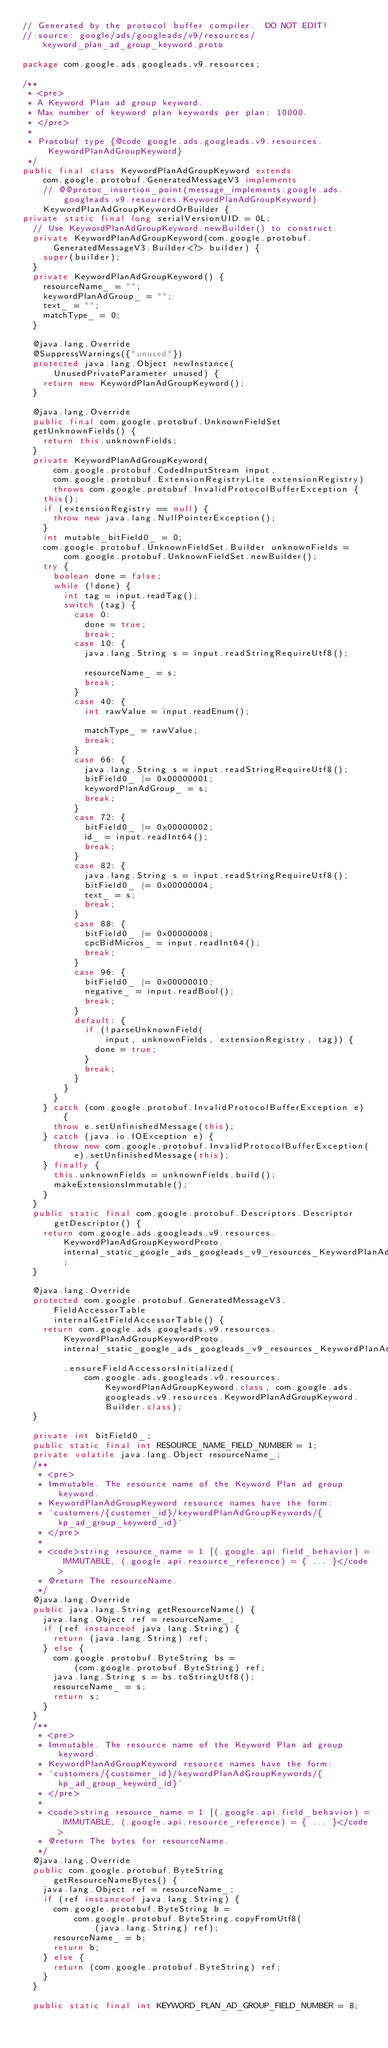Convert code to text. <code><loc_0><loc_0><loc_500><loc_500><_Java_>// Generated by the protocol buffer compiler.  DO NOT EDIT!
// source: google/ads/googleads/v9/resources/keyword_plan_ad_group_keyword.proto

package com.google.ads.googleads.v9.resources;

/**
 * <pre>
 * A Keyword Plan ad group keyword.
 * Max number of keyword plan keywords per plan: 10000.
 * </pre>
 *
 * Protobuf type {@code google.ads.googleads.v9.resources.KeywordPlanAdGroupKeyword}
 */
public final class KeywordPlanAdGroupKeyword extends
    com.google.protobuf.GeneratedMessageV3 implements
    // @@protoc_insertion_point(message_implements:google.ads.googleads.v9.resources.KeywordPlanAdGroupKeyword)
    KeywordPlanAdGroupKeywordOrBuilder {
private static final long serialVersionUID = 0L;
  // Use KeywordPlanAdGroupKeyword.newBuilder() to construct.
  private KeywordPlanAdGroupKeyword(com.google.protobuf.GeneratedMessageV3.Builder<?> builder) {
    super(builder);
  }
  private KeywordPlanAdGroupKeyword() {
    resourceName_ = "";
    keywordPlanAdGroup_ = "";
    text_ = "";
    matchType_ = 0;
  }

  @java.lang.Override
  @SuppressWarnings({"unused"})
  protected java.lang.Object newInstance(
      UnusedPrivateParameter unused) {
    return new KeywordPlanAdGroupKeyword();
  }

  @java.lang.Override
  public final com.google.protobuf.UnknownFieldSet
  getUnknownFields() {
    return this.unknownFields;
  }
  private KeywordPlanAdGroupKeyword(
      com.google.protobuf.CodedInputStream input,
      com.google.protobuf.ExtensionRegistryLite extensionRegistry)
      throws com.google.protobuf.InvalidProtocolBufferException {
    this();
    if (extensionRegistry == null) {
      throw new java.lang.NullPointerException();
    }
    int mutable_bitField0_ = 0;
    com.google.protobuf.UnknownFieldSet.Builder unknownFields =
        com.google.protobuf.UnknownFieldSet.newBuilder();
    try {
      boolean done = false;
      while (!done) {
        int tag = input.readTag();
        switch (tag) {
          case 0:
            done = true;
            break;
          case 10: {
            java.lang.String s = input.readStringRequireUtf8();

            resourceName_ = s;
            break;
          }
          case 40: {
            int rawValue = input.readEnum();

            matchType_ = rawValue;
            break;
          }
          case 66: {
            java.lang.String s = input.readStringRequireUtf8();
            bitField0_ |= 0x00000001;
            keywordPlanAdGroup_ = s;
            break;
          }
          case 72: {
            bitField0_ |= 0x00000002;
            id_ = input.readInt64();
            break;
          }
          case 82: {
            java.lang.String s = input.readStringRequireUtf8();
            bitField0_ |= 0x00000004;
            text_ = s;
            break;
          }
          case 88: {
            bitField0_ |= 0x00000008;
            cpcBidMicros_ = input.readInt64();
            break;
          }
          case 96: {
            bitField0_ |= 0x00000010;
            negative_ = input.readBool();
            break;
          }
          default: {
            if (!parseUnknownField(
                input, unknownFields, extensionRegistry, tag)) {
              done = true;
            }
            break;
          }
        }
      }
    } catch (com.google.protobuf.InvalidProtocolBufferException e) {
      throw e.setUnfinishedMessage(this);
    } catch (java.io.IOException e) {
      throw new com.google.protobuf.InvalidProtocolBufferException(
          e).setUnfinishedMessage(this);
    } finally {
      this.unknownFields = unknownFields.build();
      makeExtensionsImmutable();
    }
  }
  public static final com.google.protobuf.Descriptors.Descriptor
      getDescriptor() {
    return com.google.ads.googleads.v9.resources.KeywordPlanAdGroupKeywordProto.internal_static_google_ads_googleads_v9_resources_KeywordPlanAdGroupKeyword_descriptor;
  }

  @java.lang.Override
  protected com.google.protobuf.GeneratedMessageV3.FieldAccessorTable
      internalGetFieldAccessorTable() {
    return com.google.ads.googleads.v9.resources.KeywordPlanAdGroupKeywordProto.internal_static_google_ads_googleads_v9_resources_KeywordPlanAdGroupKeyword_fieldAccessorTable
        .ensureFieldAccessorsInitialized(
            com.google.ads.googleads.v9.resources.KeywordPlanAdGroupKeyword.class, com.google.ads.googleads.v9.resources.KeywordPlanAdGroupKeyword.Builder.class);
  }

  private int bitField0_;
  public static final int RESOURCE_NAME_FIELD_NUMBER = 1;
  private volatile java.lang.Object resourceName_;
  /**
   * <pre>
   * Immutable. The resource name of the Keyword Plan ad group keyword.
   * KeywordPlanAdGroupKeyword resource names have the form:
   * `customers/{customer_id}/keywordPlanAdGroupKeywords/{kp_ad_group_keyword_id}`
   * </pre>
   *
   * <code>string resource_name = 1 [(.google.api.field_behavior) = IMMUTABLE, (.google.api.resource_reference) = { ... }</code>
   * @return The resourceName.
   */
  @java.lang.Override
  public java.lang.String getResourceName() {
    java.lang.Object ref = resourceName_;
    if (ref instanceof java.lang.String) {
      return (java.lang.String) ref;
    } else {
      com.google.protobuf.ByteString bs = 
          (com.google.protobuf.ByteString) ref;
      java.lang.String s = bs.toStringUtf8();
      resourceName_ = s;
      return s;
    }
  }
  /**
   * <pre>
   * Immutable. The resource name of the Keyword Plan ad group keyword.
   * KeywordPlanAdGroupKeyword resource names have the form:
   * `customers/{customer_id}/keywordPlanAdGroupKeywords/{kp_ad_group_keyword_id}`
   * </pre>
   *
   * <code>string resource_name = 1 [(.google.api.field_behavior) = IMMUTABLE, (.google.api.resource_reference) = { ... }</code>
   * @return The bytes for resourceName.
   */
  @java.lang.Override
  public com.google.protobuf.ByteString
      getResourceNameBytes() {
    java.lang.Object ref = resourceName_;
    if (ref instanceof java.lang.String) {
      com.google.protobuf.ByteString b = 
          com.google.protobuf.ByteString.copyFromUtf8(
              (java.lang.String) ref);
      resourceName_ = b;
      return b;
    } else {
      return (com.google.protobuf.ByteString) ref;
    }
  }

  public static final int KEYWORD_PLAN_AD_GROUP_FIELD_NUMBER = 8;</code> 